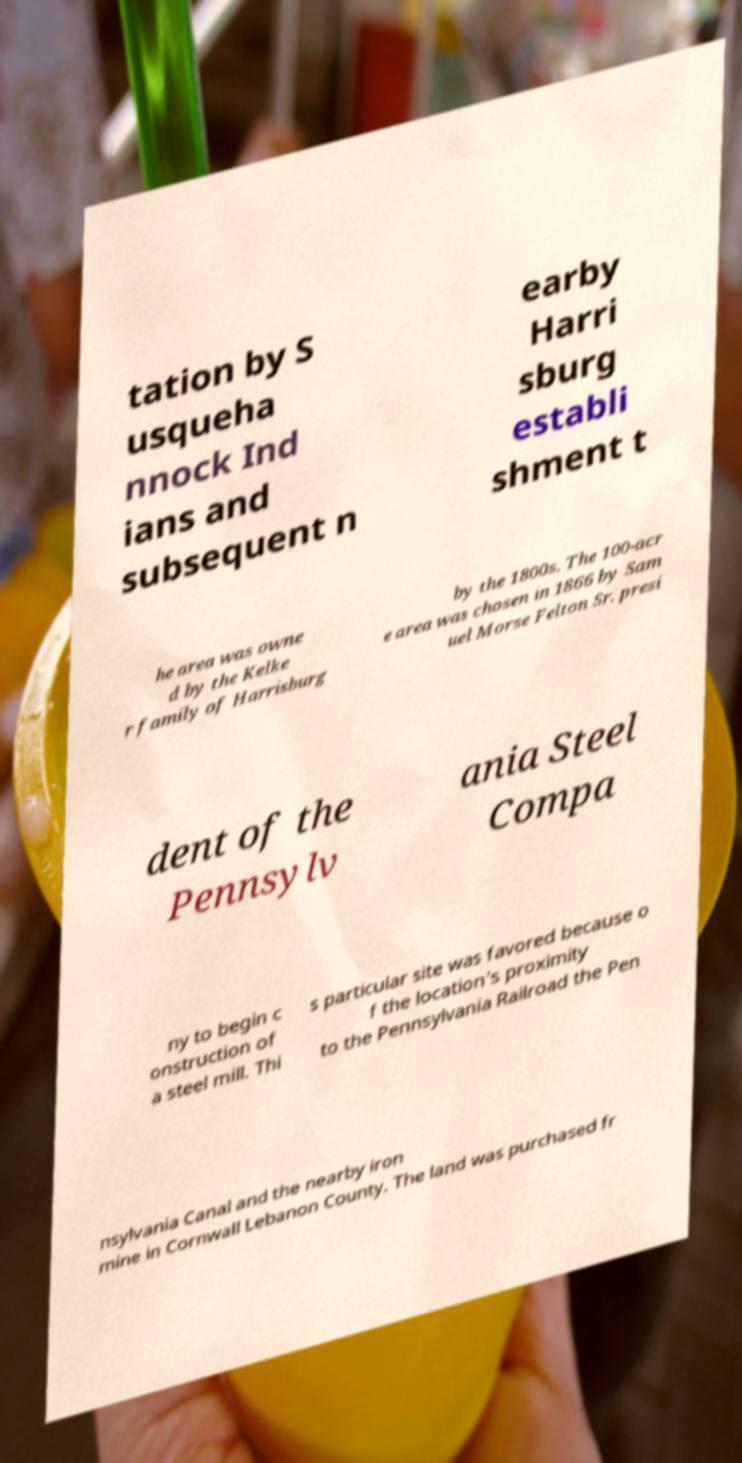Please identify and transcribe the text found in this image. tation by S usqueha nnock Ind ians and subsequent n earby Harri sburg establi shment t he area was owne d by the Kelke r family of Harrisburg by the 1800s. The 100-acr e area was chosen in 1866 by Sam uel Morse Felton Sr. presi dent of the Pennsylv ania Steel Compa ny to begin c onstruction of a steel mill. Thi s particular site was favored because o f the location's proximity to the Pennsylvania Railroad the Pen nsylvania Canal and the nearby iron mine in Cornwall Lebanon County. The land was purchased fr 